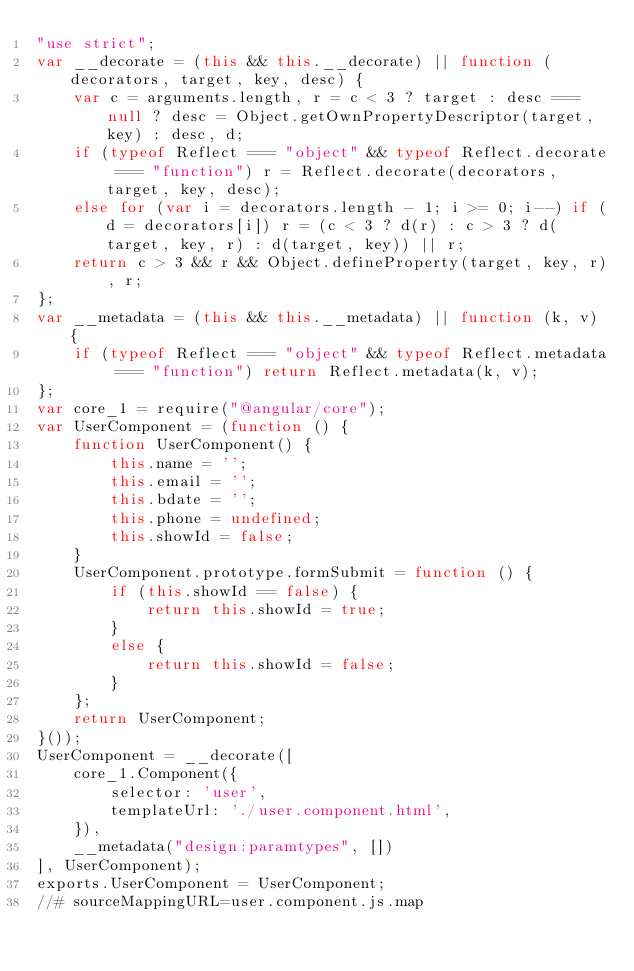Convert code to text. <code><loc_0><loc_0><loc_500><loc_500><_JavaScript_>"use strict";
var __decorate = (this && this.__decorate) || function (decorators, target, key, desc) {
    var c = arguments.length, r = c < 3 ? target : desc === null ? desc = Object.getOwnPropertyDescriptor(target, key) : desc, d;
    if (typeof Reflect === "object" && typeof Reflect.decorate === "function") r = Reflect.decorate(decorators, target, key, desc);
    else for (var i = decorators.length - 1; i >= 0; i--) if (d = decorators[i]) r = (c < 3 ? d(r) : c > 3 ? d(target, key, r) : d(target, key)) || r;
    return c > 3 && r && Object.defineProperty(target, key, r), r;
};
var __metadata = (this && this.__metadata) || function (k, v) {
    if (typeof Reflect === "object" && typeof Reflect.metadata === "function") return Reflect.metadata(k, v);
};
var core_1 = require("@angular/core");
var UserComponent = (function () {
    function UserComponent() {
        this.name = '';
        this.email = '';
        this.bdate = '';
        this.phone = undefined;
        this.showId = false;
    }
    UserComponent.prototype.formSubmit = function () {
        if (this.showId == false) {
            return this.showId = true;
        }
        else {
            return this.showId = false;
        }
    };
    return UserComponent;
}());
UserComponent = __decorate([
    core_1.Component({
        selector: 'user',
        templateUrl: './user.component.html',
    }),
    __metadata("design:paramtypes", [])
], UserComponent);
exports.UserComponent = UserComponent;
//# sourceMappingURL=user.component.js.map</code> 